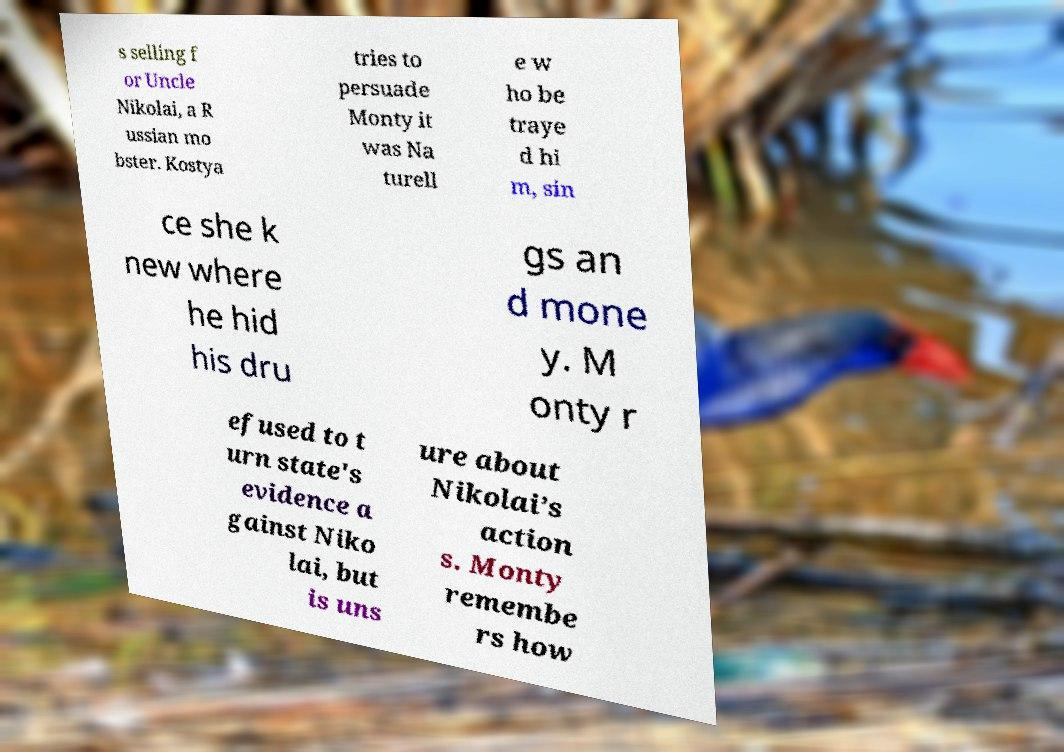Please identify and transcribe the text found in this image. s selling f or Uncle Nikolai, a R ussian mo bster. Kostya tries to persuade Monty it was Na turell e w ho be traye d hi m, sin ce she k new where he hid his dru gs an d mone y. M onty r efused to t urn state's evidence a gainst Niko lai, but is uns ure about Nikolai’s action s. Monty remembe rs how 